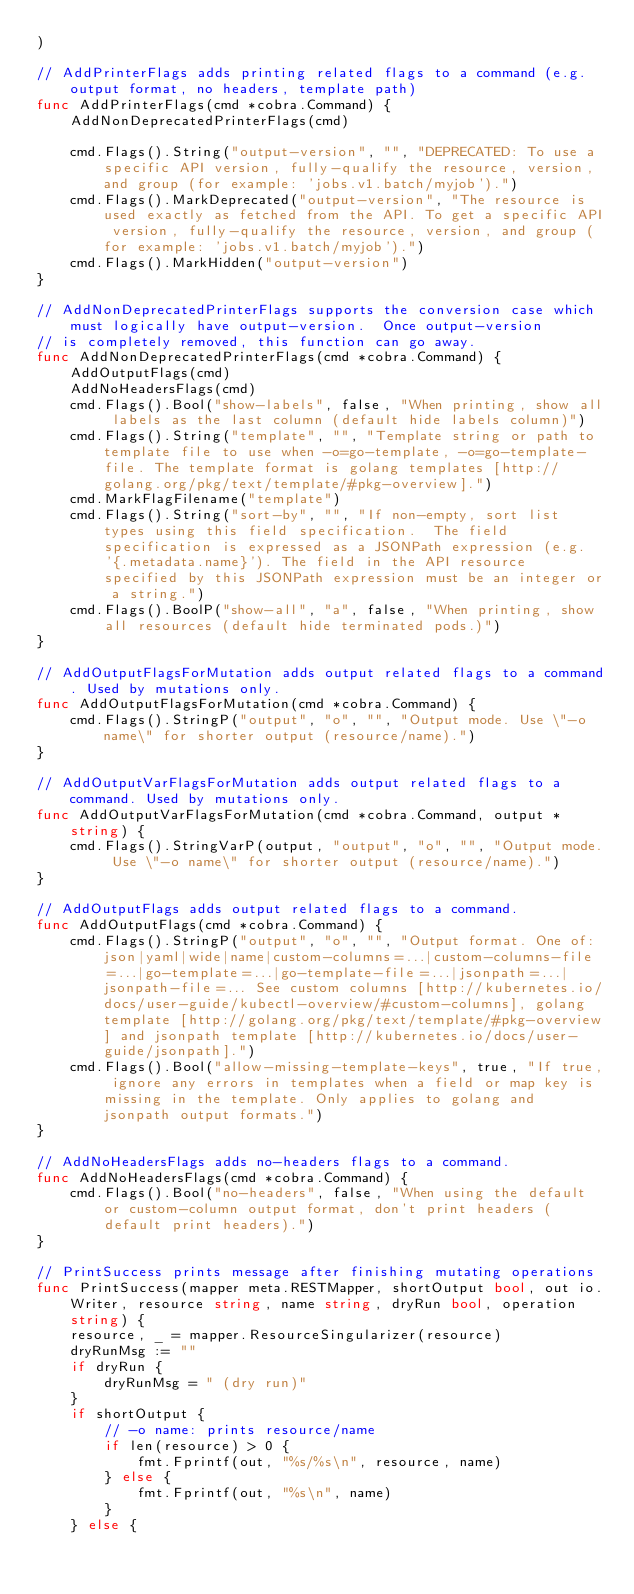<code> <loc_0><loc_0><loc_500><loc_500><_Go_>)

// AddPrinterFlags adds printing related flags to a command (e.g. output format, no headers, template path)
func AddPrinterFlags(cmd *cobra.Command) {
	AddNonDeprecatedPrinterFlags(cmd)

	cmd.Flags().String("output-version", "", "DEPRECATED: To use a specific API version, fully-qualify the resource, version, and group (for example: 'jobs.v1.batch/myjob').")
	cmd.Flags().MarkDeprecated("output-version", "The resource is used exactly as fetched from the API. To get a specific API version, fully-qualify the resource, version, and group (for example: 'jobs.v1.batch/myjob').")
	cmd.Flags().MarkHidden("output-version")
}

// AddNonDeprecatedPrinterFlags supports the conversion case which must logically have output-version.  Once output-version
// is completely removed, this function can go away.
func AddNonDeprecatedPrinterFlags(cmd *cobra.Command) {
	AddOutputFlags(cmd)
	AddNoHeadersFlags(cmd)
	cmd.Flags().Bool("show-labels", false, "When printing, show all labels as the last column (default hide labels column)")
	cmd.Flags().String("template", "", "Template string or path to template file to use when -o=go-template, -o=go-template-file. The template format is golang templates [http://golang.org/pkg/text/template/#pkg-overview].")
	cmd.MarkFlagFilename("template")
	cmd.Flags().String("sort-by", "", "If non-empty, sort list types using this field specification.  The field specification is expressed as a JSONPath expression (e.g. '{.metadata.name}'). The field in the API resource specified by this JSONPath expression must be an integer or a string.")
	cmd.Flags().BoolP("show-all", "a", false, "When printing, show all resources (default hide terminated pods.)")
}

// AddOutputFlagsForMutation adds output related flags to a command. Used by mutations only.
func AddOutputFlagsForMutation(cmd *cobra.Command) {
	cmd.Flags().StringP("output", "o", "", "Output mode. Use \"-o name\" for shorter output (resource/name).")
}

// AddOutputVarFlagsForMutation adds output related flags to a command. Used by mutations only.
func AddOutputVarFlagsForMutation(cmd *cobra.Command, output *string) {
	cmd.Flags().StringVarP(output, "output", "o", "", "Output mode. Use \"-o name\" for shorter output (resource/name).")
}

// AddOutputFlags adds output related flags to a command.
func AddOutputFlags(cmd *cobra.Command) {
	cmd.Flags().StringP("output", "o", "", "Output format. One of: json|yaml|wide|name|custom-columns=...|custom-columns-file=...|go-template=...|go-template-file=...|jsonpath=...|jsonpath-file=... See custom columns [http://kubernetes.io/docs/user-guide/kubectl-overview/#custom-columns], golang template [http://golang.org/pkg/text/template/#pkg-overview] and jsonpath template [http://kubernetes.io/docs/user-guide/jsonpath].")
	cmd.Flags().Bool("allow-missing-template-keys", true, "If true, ignore any errors in templates when a field or map key is missing in the template. Only applies to golang and jsonpath output formats.")
}

// AddNoHeadersFlags adds no-headers flags to a command.
func AddNoHeadersFlags(cmd *cobra.Command) {
	cmd.Flags().Bool("no-headers", false, "When using the default or custom-column output format, don't print headers (default print headers).")
}

// PrintSuccess prints message after finishing mutating operations
func PrintSuccess(mapper meta.RESTMapper, shortOutput bool, out io.Writer, resource string, name string, dryRun bool, operation string) {
	resource, _ = mapper.ResourceSingularizer(resource)
	dryRunMsg := ""
	if dryRun {
		dryRunMsg = " (dry run)"
	}
	if shortOutput {
		// -o name: prints resource/name
		if len(resource) > 0 {
			fmt.Fprintf(out, "%s/%s\n", resource, name)
		} else {
			fmt.Fprintf(out, "%s\n", name)
		}
	} else {</code> 